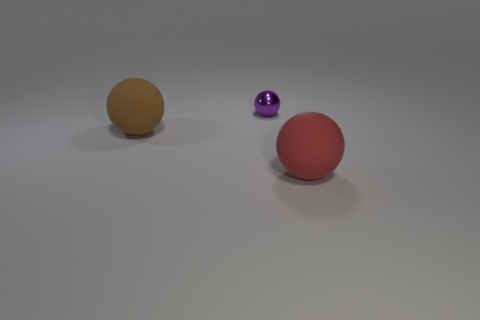Subtract all matte spheres. How many spheres are left? 1 Add 3 cyan things. How many objects exist? 6 Subtract all red balls. How many balls are left? 2 Subtract 0 brown cylinders. How many objects are left? 3 Subtract 3 spheres. How many spheres are left? 0 Subtract all green spheres. Subtract all red blocks. How many spheres are left? 3 Subtract all gray blocks. How many green spheres are left? 0 Subtract all tiny blue matte cubes. Subtract all small spheres. How many objects are left? 2 Add 1 large red balls. How many large red balls are left? 2 Add 3 large spheres. How many large spheres exist? 5 